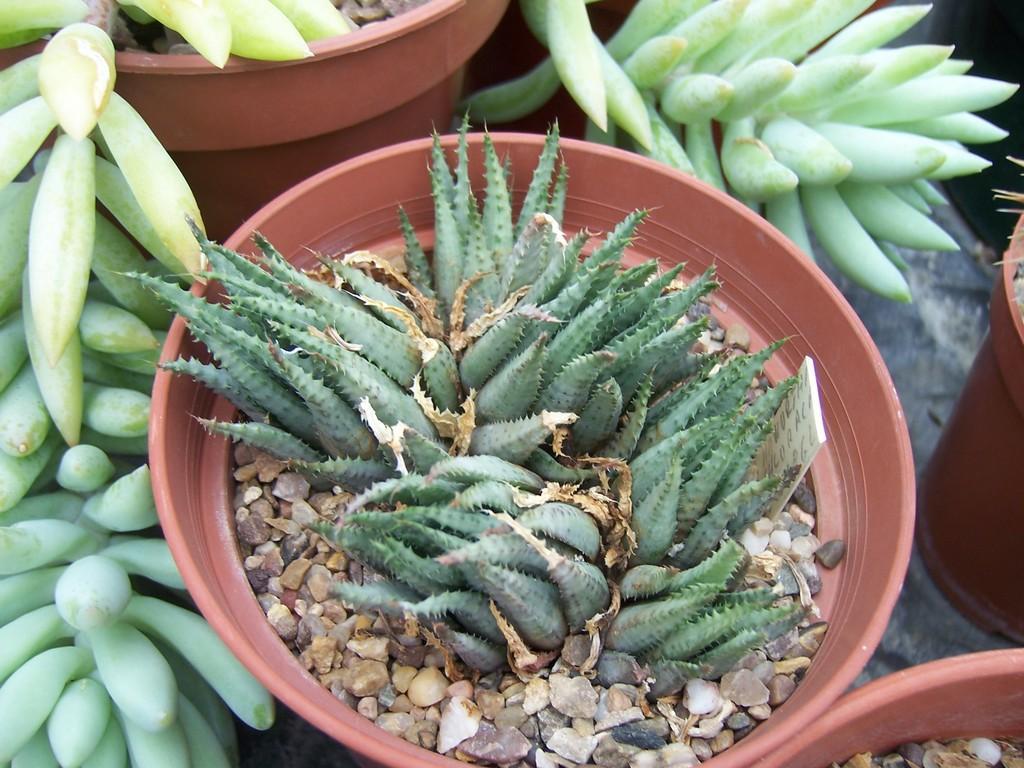In one or two sentences, can you explain what this image depicts? In this image, there is a flower pot, in that there are some green color aloe Vera plants, there are some green color objects. 